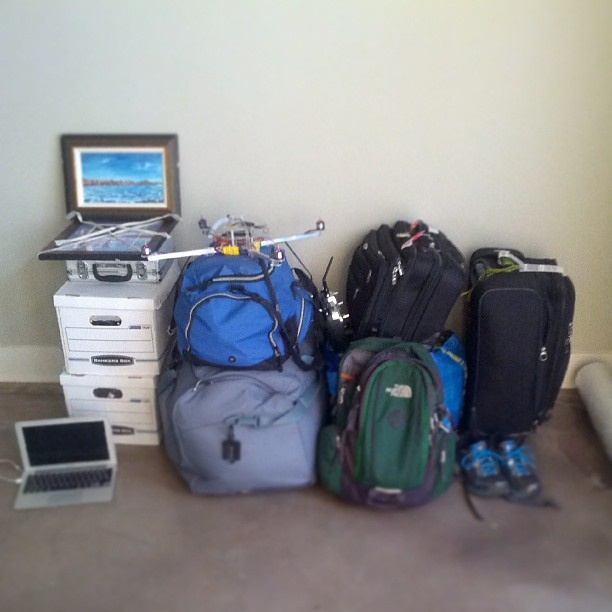Describe the objects in this image and their specific colors. I can see suitcase in lightgray, black, gray, and darkgray tones, backpack in lightgray, teal, black, and gray tones, handbag in lightgray, blue, and navy tones, laptop in lightgray, gray, lightblue, and darkgray tones, and suitcase in lightgray, black, gray, and darkgray tones in this image. 